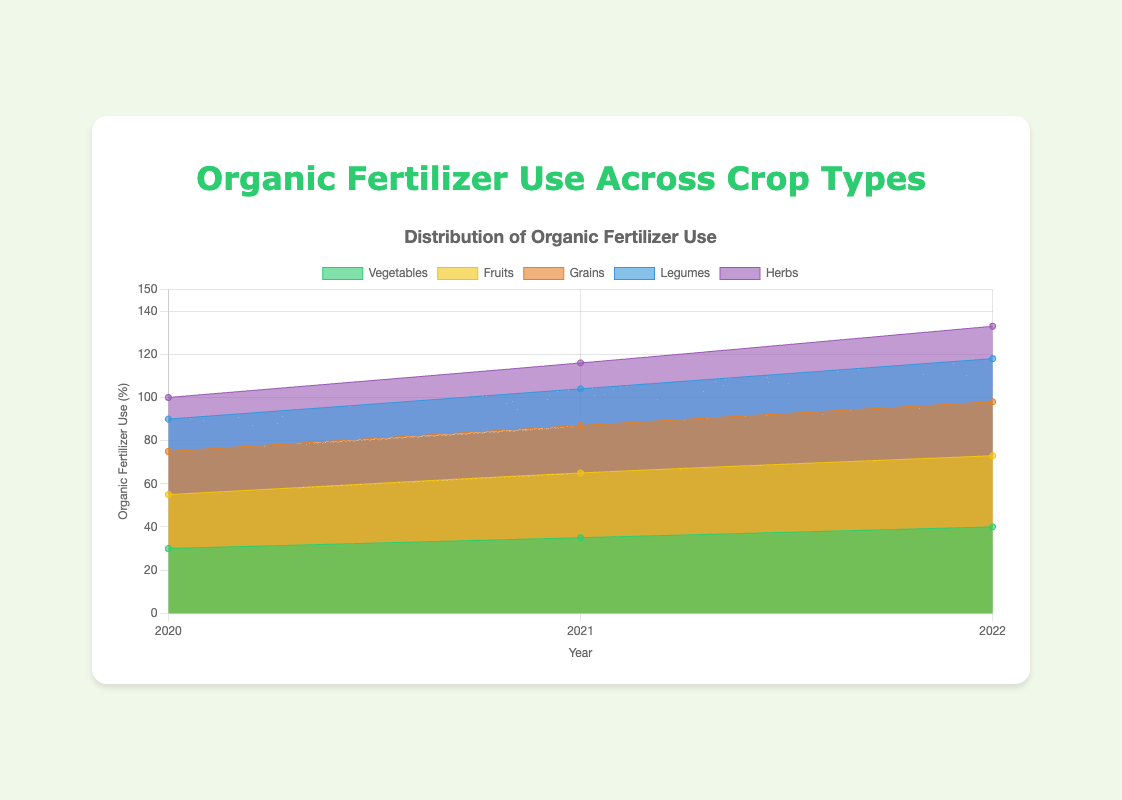What is the title of the chart? The title is usually displayed at the top of the chart. Here it is placed within an \<h1\> tag in the rendered HTML.
Answer: Organic Fertilizer Use Across Crop Types Which crop type had the highest organic fertilizer use in 2022? Look at the 2022 data points and see the highest value. Vegetables have the highest value at 40.
Answer: Vegetables What crop type had the lowest organic fertilizer use in 2020? Look at the 2020 data points and locate the smallest value. Herbs have the lowest value at 10.
Answer: Herbs By how much did organic fertilizer use for Fruits increase from 2020 to 2022? Subtract the Fertilizer use in 2020 for Fruits (25) from the usage in 2022 (33). 33 - 25 = 8.
Answer: 8 What is the range of organic fertilizer use for Grains from 2020 to 2022? The range is calculated as the difference between the highest and lowest values. For Grains, this is 25 (2022) - 20 (2020).
Answer: 5 What is the total organic fertilizer use for all crop types combined in 2021? Sum up the organic fertilizer use for all crop types in 2021: 35 (Vegetables) + 30 (Fruits) + 22 (Grains) + 17 (Legumes) + 12 (Herbs) = 116.
Answer: 116 Which crop types show a consistent increase in organic fertilizer use over the years 2020 to 2022? Check each crop type’s values for a pattern of consistent increase from 2020 to 2022. All crop types display a consistent increase.
Answer: All crop types What is the average annual increase in organic fertilizer use for Vegetables from 2020 to 2022? Find the total increase from 2020 to 2022 and then divide by the number of years: (40 - 30) / 2 = 5.
Answer: 5 